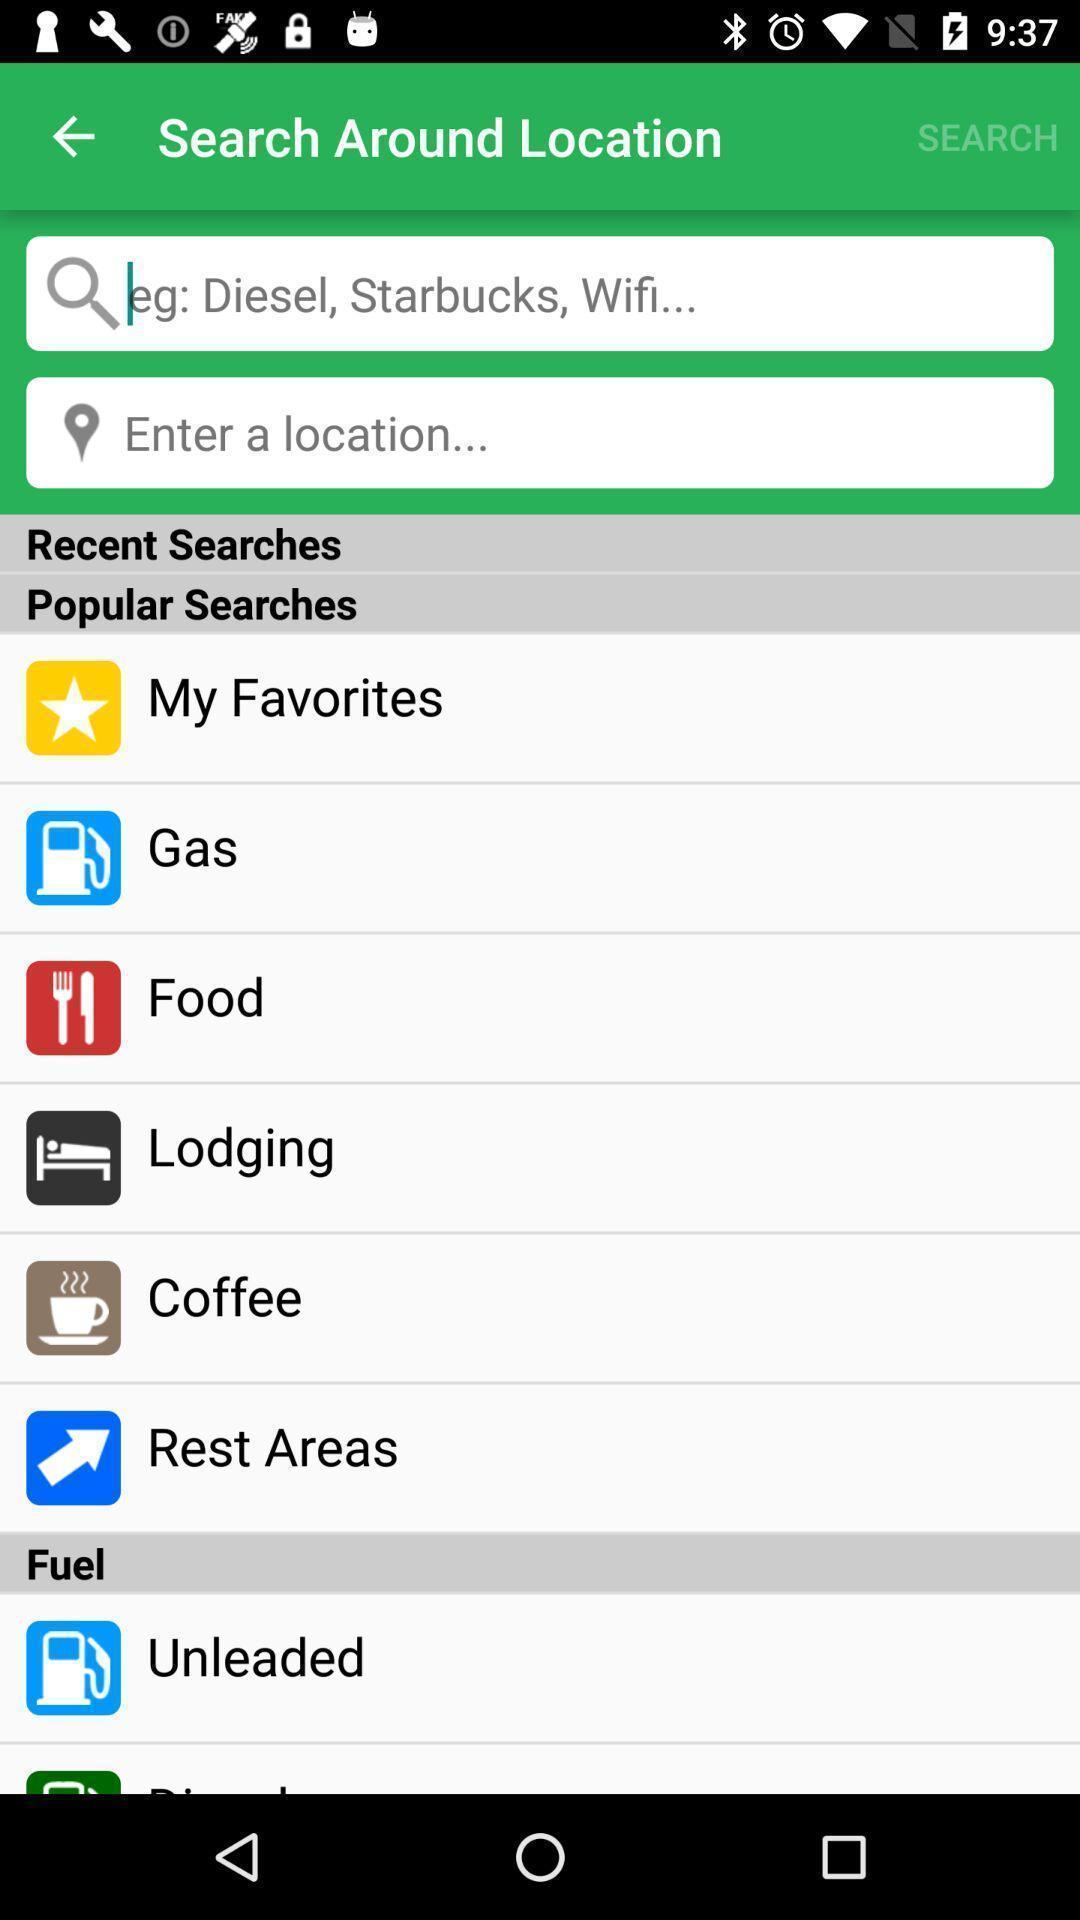Explain the elements present in this screenshot. Search page with options to search things entering the location. 